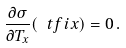<formula> <loc_0><loc_0><loc_500><loc_500>\frac { \partial \sigma } { \partial T _ { x } } ( \mathbf \ t f i x ) = 0 \, .</formula> 